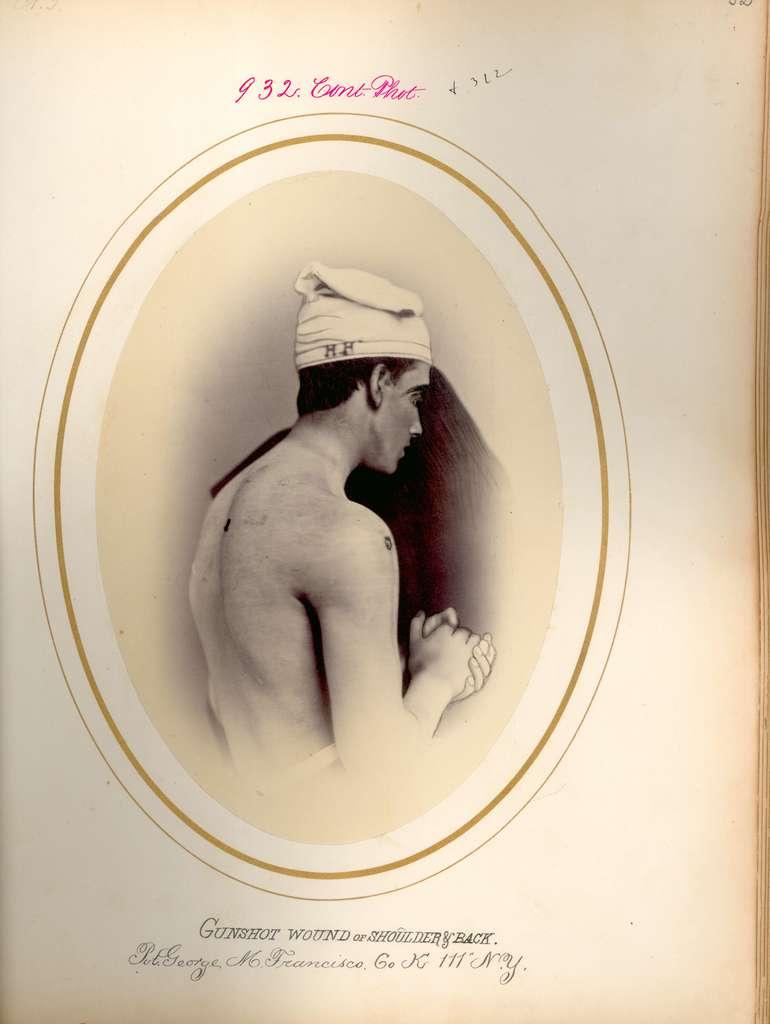What is the main subject of the image? There is a photograph in the image. What type of ear is visible in the photograph? There is no ear visible in the photograph; the image only contains a photograph itself. 